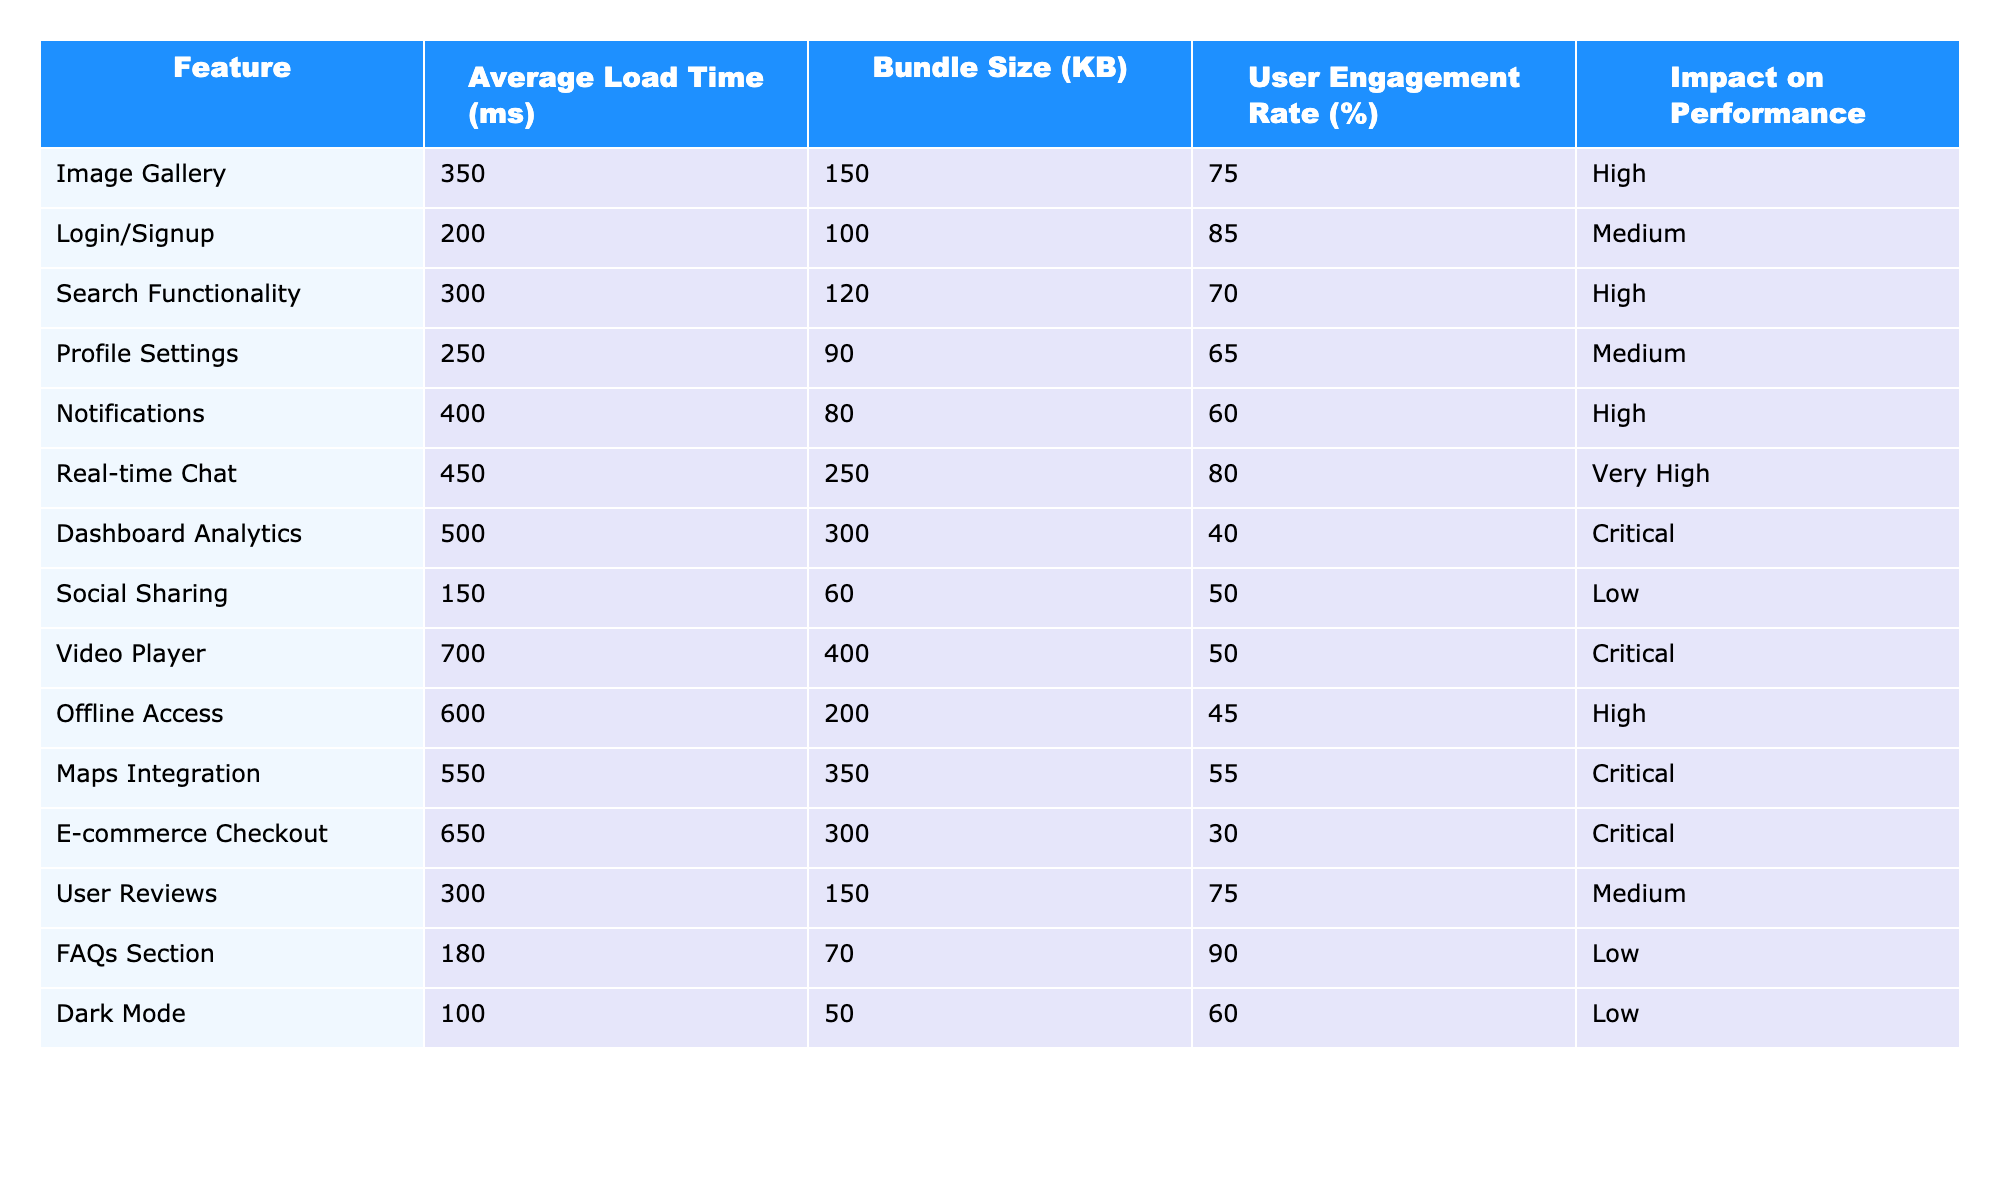What is the average load time of the Image Gallery feature? The table states that the average load time for the Image Gallery is 350 ms.
Answer: 350 ms Which feature has the largest bundle size? By looking at the Bundle Size column, the Video Player has the largest size at 400 KB.
Answer: Video Player Is the Notification feature considered critical in terms of its performance impact? The table categorizes Notifications as High impact, which is not critical.
Answer: No What is the average bundle size of features classified as Critical? The Critical features are Dashboard Analytics, Video Player, Maps Integration, and E-commerce Checkout. Their bundle sizes are 300, 400, 350, and 300 KB, summing to 1350 KB. There are 4 features, so the average is 1350/4 = 337.5 KB.
Answer: 337.5 KB How many features have a user engagement rate above 70%? By examining the User Engagement Rate column, we note that Image Gallery (75%), Login/Signup (85%), Real-time Chat (80%), and User Reviews (75%) meet the criteria, resulting in 4 features.
Answer: 4 What is the difference in average load time between the Real-time Chat and Social Sharing features? The average load time for Real-time Chat is 450 ms, while Social Sharing is 150 ms. The difference is 450 - 150 = 300 ms.
Answer: 300 ms Does the Offline Access feature have a better performance impact than the E-commerce Checkout? Offline Access is rated High impact, while E-commerce Checkout is rated Critical. Since Critical is worse than High, Offline Access has better performance impact.
Answer: Yes What is the total load time of features with a user engagement rate above 60%? The relevant features are Image Gallery (350 ms), Login/Signup (200 ms), Real-time Chat (450 ms), User Reviews (300 ms), and FAQs Section (180 ms). Their total is 350 + 200 + 450 + 300 + 180 = 1480 ms.
Answer: 1480 ms Which feature has the lowest user engagement rate and what is that rate? After reviewing the User Engagement Rate, the E-commerce Checkout feature has the lowest rate at 30%.
Answer: 30% If you were to prioritize improvements based on Impact on Performance, which features should be targeted first? The features with Critical impact are Dashboard Analytics, Video Player, Maps Integration, and E-commerce Checkout. Therefore, these should be prioritized for improvements.
Answer: Dashboard Analytics, Video Player, Maps Integration, E-commerce Checkout 